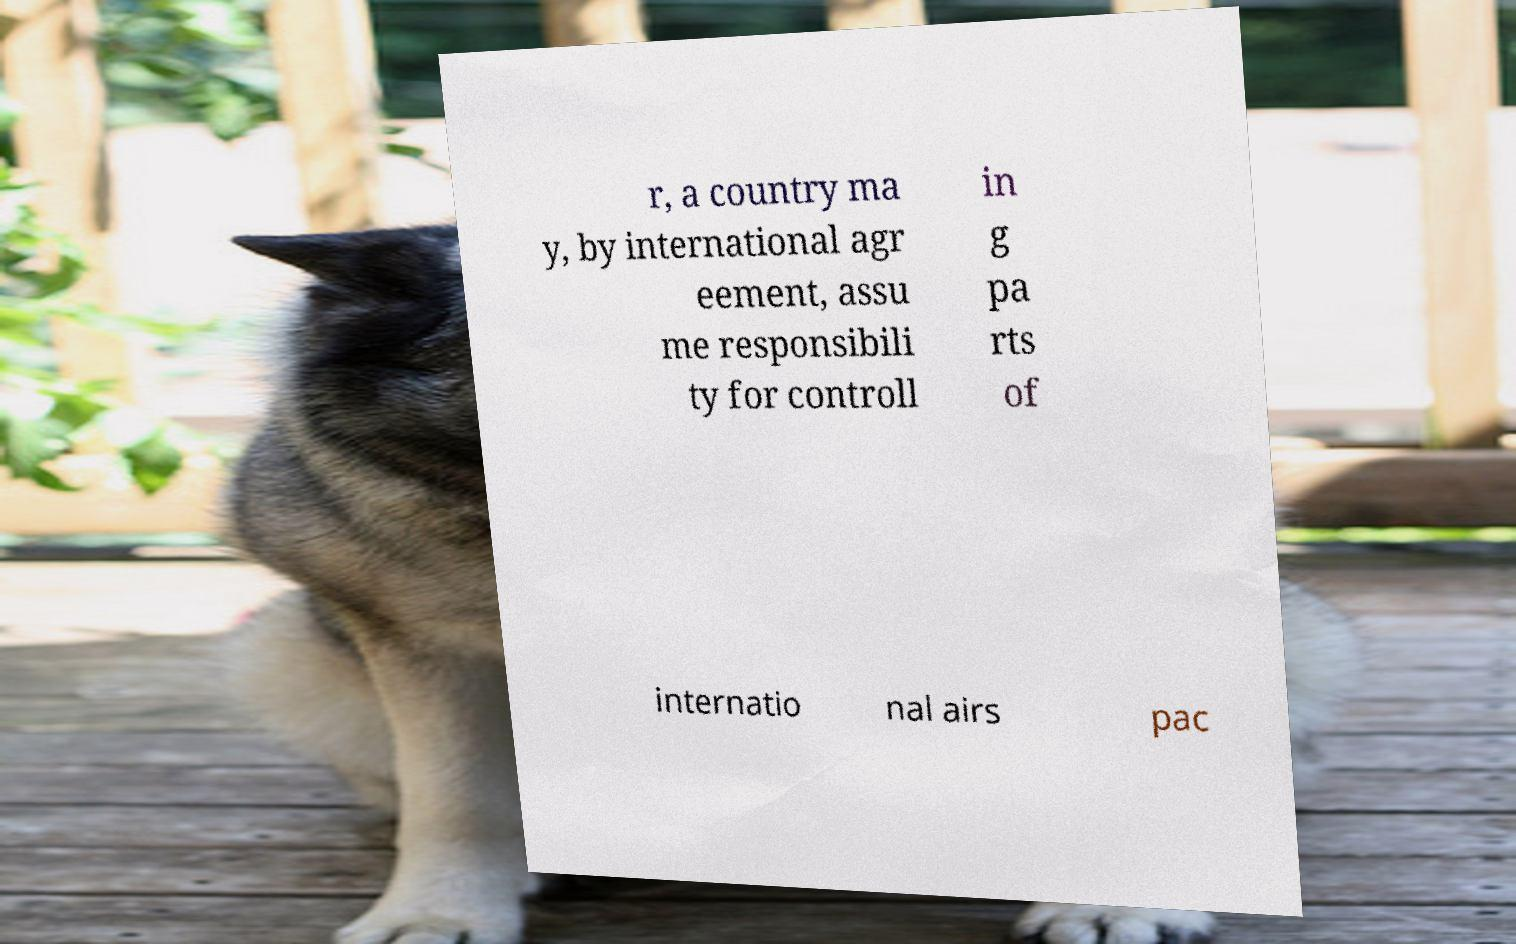Could you assist in decoding the text presented in this image and type it out clearly? r, a country ma y, by international agr eement, assu me responsibili ty for controll in g pa rts of internatio nal airs pac 